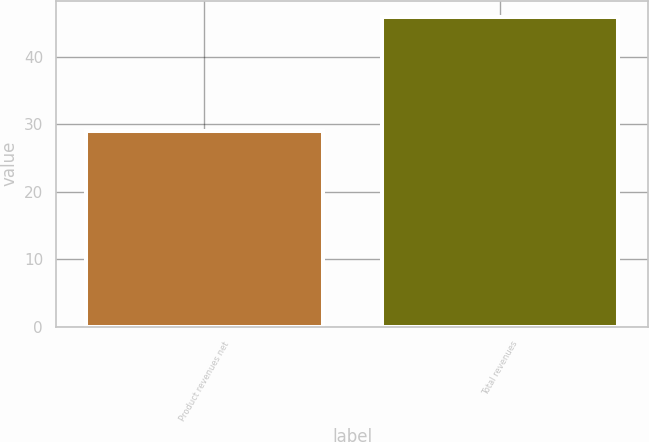Convert chart. <chart><loc_0><loc_0><loc_500><loc_500><bar_chart><fcel>Product revenues net<fcel>Total revenues<nl><fcel>29<fcel>46<nl></chart> 